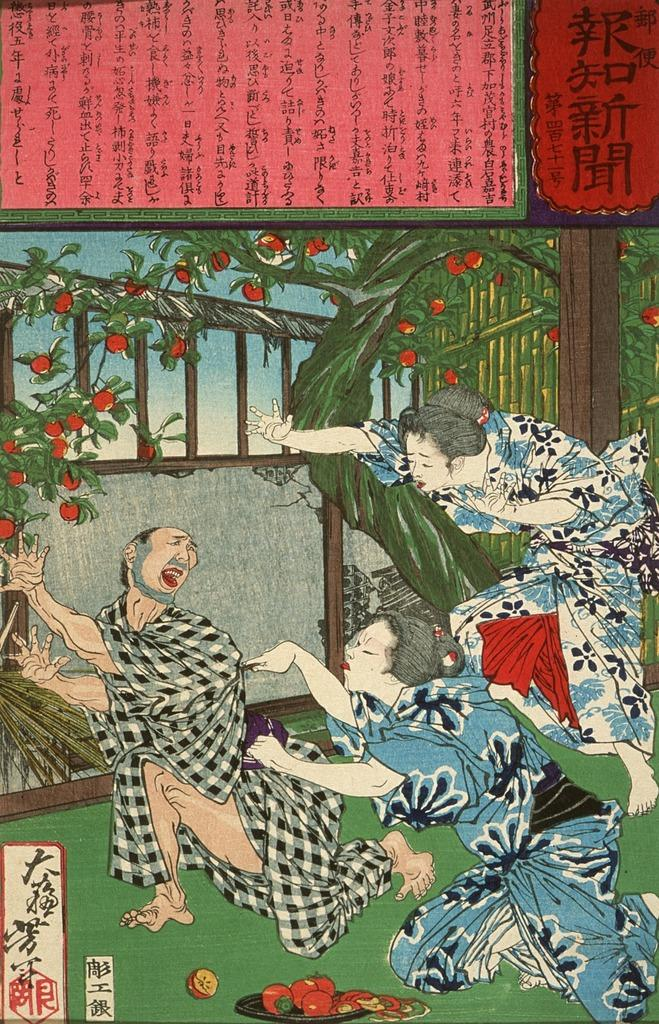What is the main subject in the center of the image? There is a poster in the center of the image. What type of lift can be seen in the image? There is no lift present in the image; it only features a poster. What journey is depicted on the poster in the image? The provided facts do not mention any journey or specific content on the poster, so we cannot answer this question. 